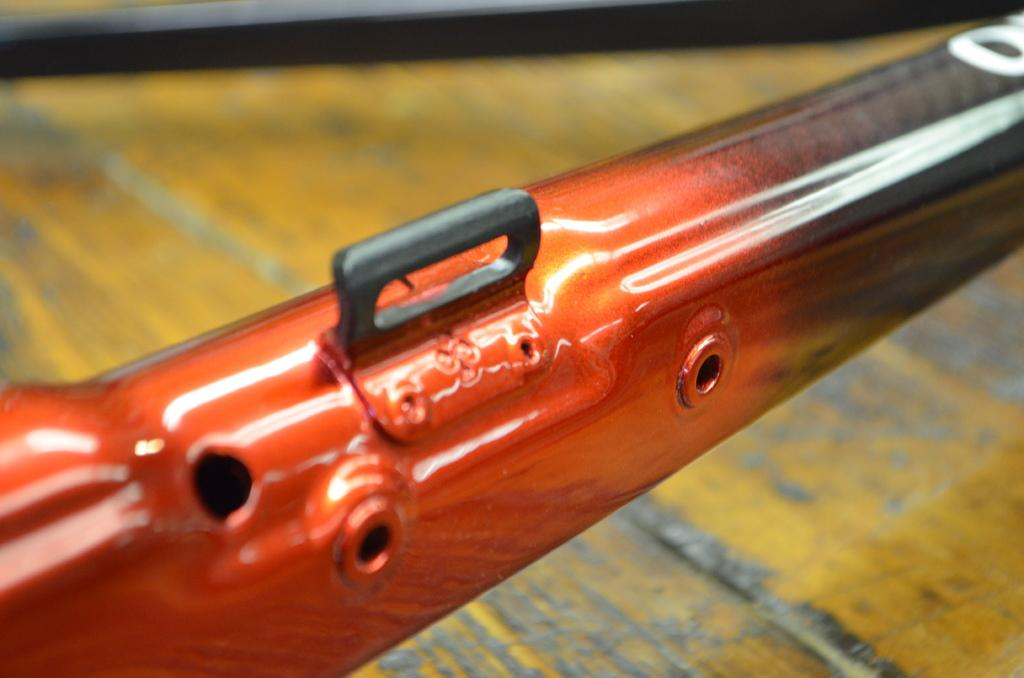What can you describe the objects in the image? There are colorful objects in the image. What can be said about the background of the image? The background of the image is blurred. How many chickens are visible in the image? There are no chickens present in the image. What is the reason for the colorful objects to cry in the image? The colorful objects in the image are not capable of crying, as they are inanimate objects. 